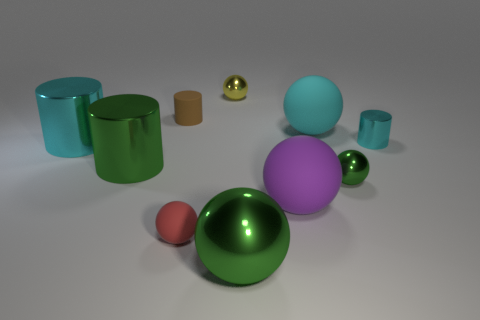Subtract 1 balls. How many balls are left? 5 Subtract all cyan spheres. How many spheres are left? 5 Subtract all tiny yellow shiny spheres. How many spheres are left? 5 Subtract all red balls. Subtract all green blocks. How many balls are left? 5 Subtract all cylinders. How many objects are left? 6 Subtract all brown rubber things. Subtract all large cyan matte things. How many objects are left? 8 Add 2 purple rubber balls. How many purple rubber balls are left? 3 Add 7 brown matte things. How many brown matte things exist? 8 Subtract 0 gray cubes. How many objects are left? 10 